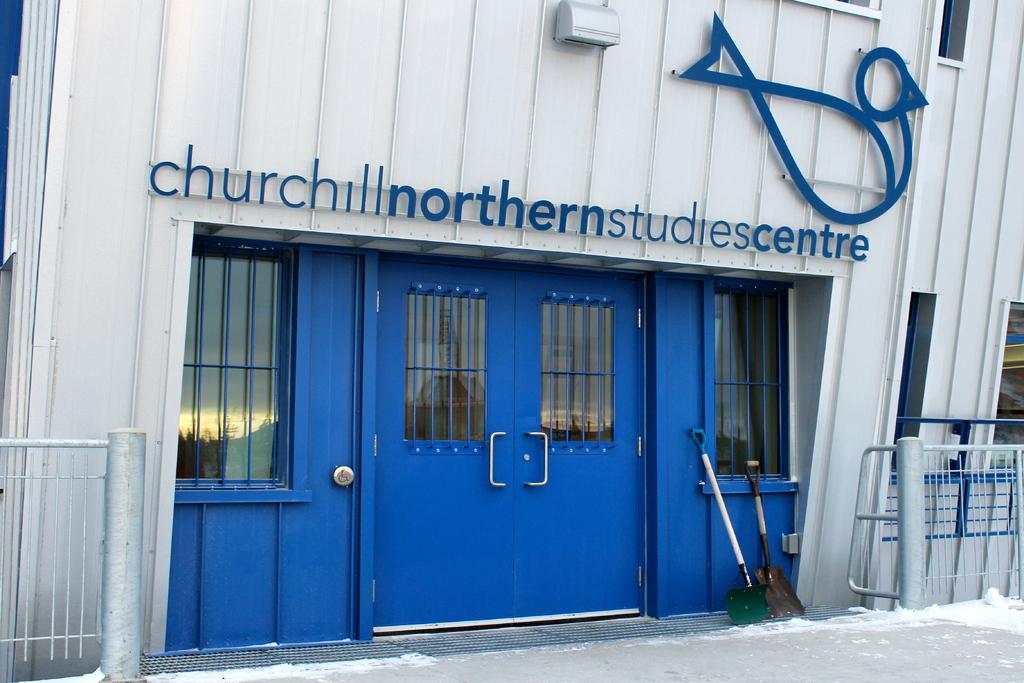Whats the name of this building?
Give a very brief answer. Churchill northern studies centre. 